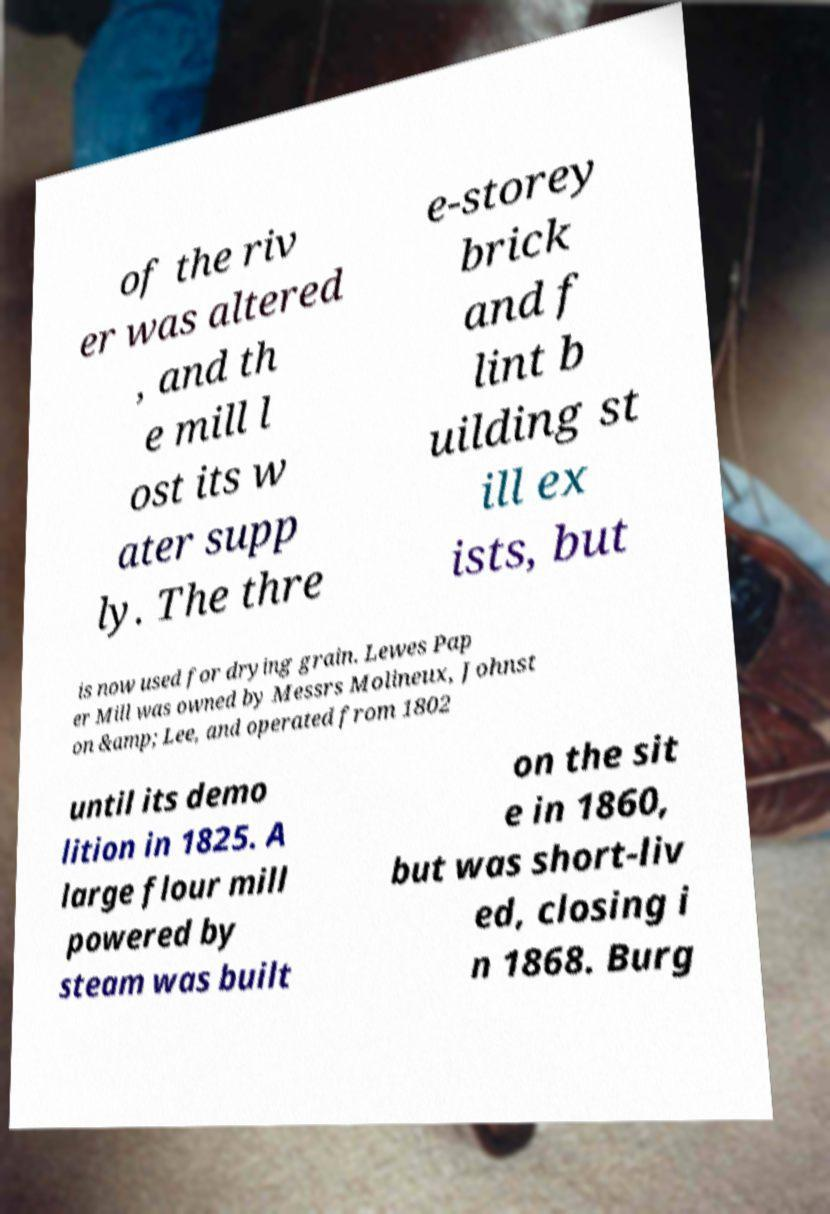Please read and relay the text visible in this image. What does it say? of the riv er was altered , and th e mill l ost its w ater supp ly. The thre e-storey brick and f lint b uilding st ill ex ists, but is now used for drying grain. Lewes Pap er Mill was owned by Messrs Molineux, Johnst on &amp; Lee, and operated from 1802 until its demo lition in 1825. A large flour mill powered by steam was built on the sit e in 1860, but was short-liv ed, closing i n 1868. Burg 